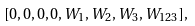<formula> <loc_0><loc_0><loc_500><loc_500>[ 0 , 0 , 0 , 0 , W _ { 1 } , W _ { 2 } , W _ { 3 } , W _ { 1 2 3 } ] ,</formula> 